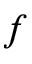Convert formula to latex. <formula><loc_0><loc_0><loc_500><loc_500>f</formula> 